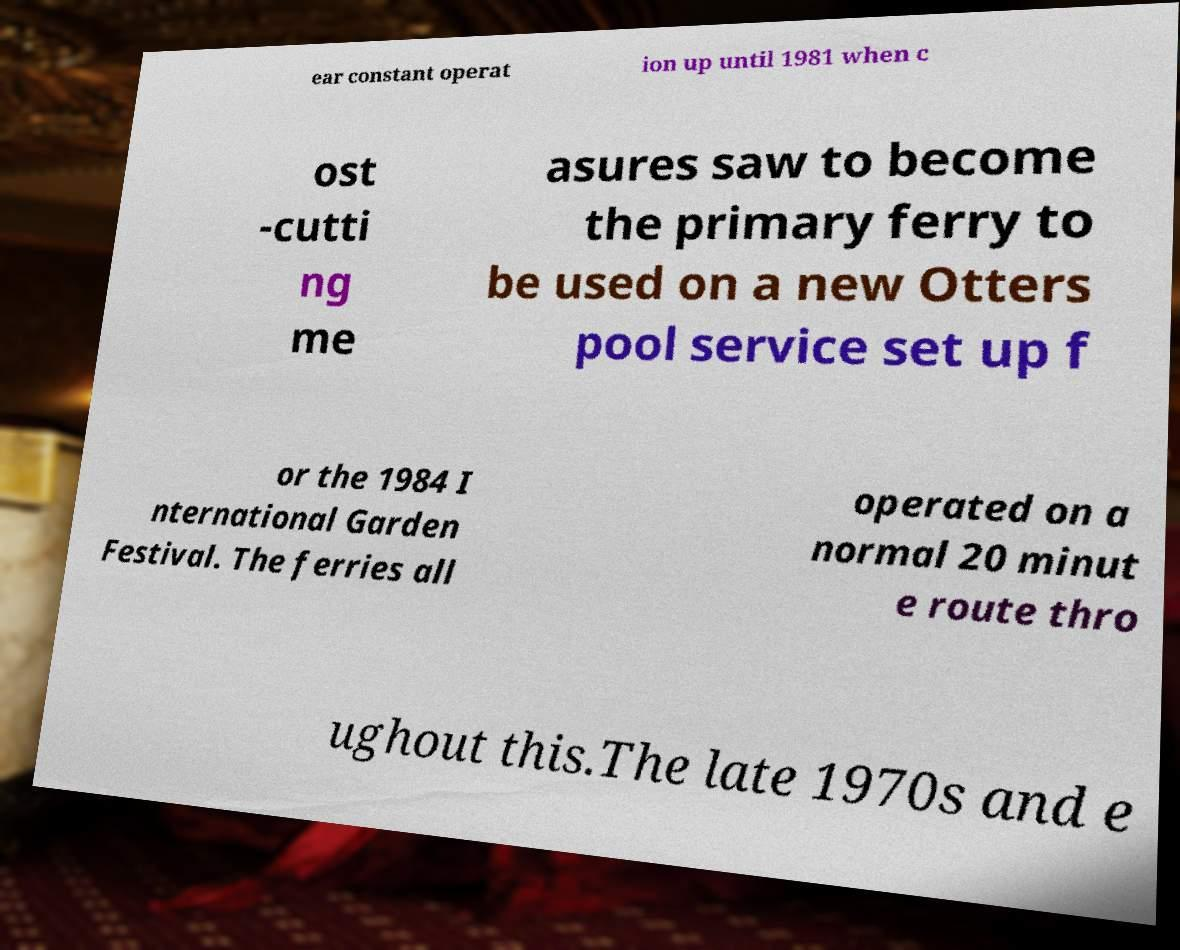There's text embedded in this image that I need extracted. Can you transcribe it verbatim? ear constant operat ion up until 1981 when c ost -cutti ng me asures saw to become the primary ferry to be used on a new Otters pool service set up f or the 1984 I nternational Garden Festival. The ferries all operated on a normal 20 minut e route thro ughout this.The late 1970s and e 